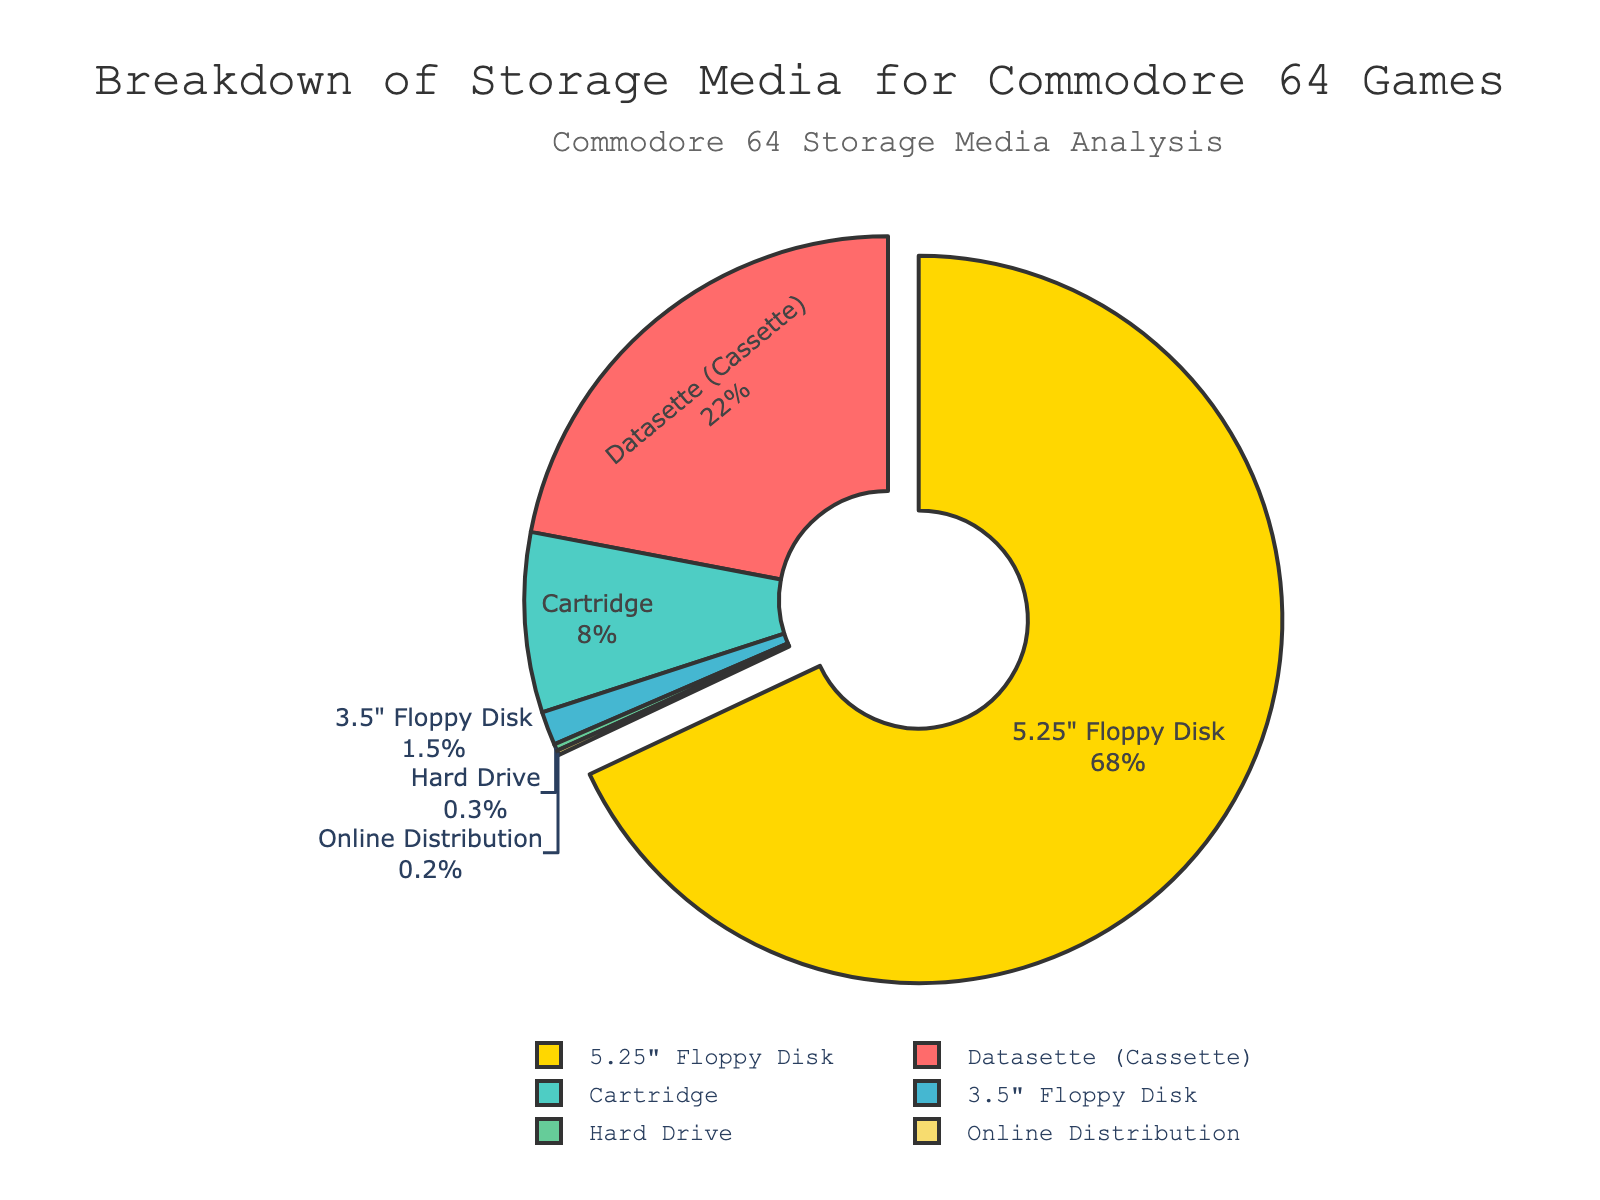Which storage medium is used the most for Commodore 64 games? The pie chart shows the largest segment for the 5.25" Floppy Disk, which is pulled out slightly more than the other sections. This indicates it's the most used storage medium.
Answer: 5.25" Floppy Disk Which two storage media combined make up less than 1% of the total? By observing the smallest segments in the pie chart ('Hard Drive' and 'Online Distribution'), we can see their percentages (0.3% and 0.2%, respectively) add up to only 0.5%.
Answer: Hard Drive and Online Distribution What percentage of Commodore 64 games use cartridges? The pie chart includes percentage labels, and the label for 'Cartridge' shows 8%.
Answer: 8% How much more popular is the 5.25" Floppy Disk compared to the Datasette? The 5.25" Floppy Disk makes up 68%, while the Datasette makes up 22%. Subtracting these values gives the difference: 68% - 22% = 46%.
Answer: 46% Which storage media types constitute over 90% of all media combined? Adding the percentages of the largest segments (5.25" Floppy Disk at 68% and Datasette at 22%) totals to 90%, exactly the threshold. Including any smaller segment will push it over 90%.
Answer: 5.25" Floppy Disk and Datasette What is the combined percentage of the three least used storage media types? The segments for '3.5" Floppy Disk', 'Hard Drive', and 'Online Distribution' have shares of 1.5%, 0.3%, and 0.2%, respectively. Adding these gives: 1.5% + 0.3% + 0.2% = 2%.
Answer: 2% Name the storage medium with the smallest representation and its percentage. From examining the smallest segment in the pie chart, 'Online Distribution' is the most minor with a label showing 0.2%.
Answer: Online Distribution, 0.2% What is the difference in percentage between the use of cartridges and 3.5" floppy disks? The 'Cartridge' segment shows 8%, and '3.5" Floppy Disk' shows 1.5%. Subtracting these gives: 8% - 1.5% = 6.5%.
Answer: 6.5% How does the use of the Datasette compare to all other storage media combined? First, find the total percentage of all media other than the Datasette by summing the remaining percentages (68% + 8% + 1.5% + 0.3% + 0.2% = 78%). The percentage for the Datasette itself is 22%. Thus, 22% compared to 78% for all others.
Answer: Datasette: 22%, Others: 78% How much more common are floppy disks (5.25" and 3.5") compared to cartridges? Combining the two floppy disk percentages: 68% (5.25") + 1.5% (3.5") = 69.5%. Subtracting the cartridge percentage from this: 69.5% - 8% = 61.5%.
Answer: 61.5% 